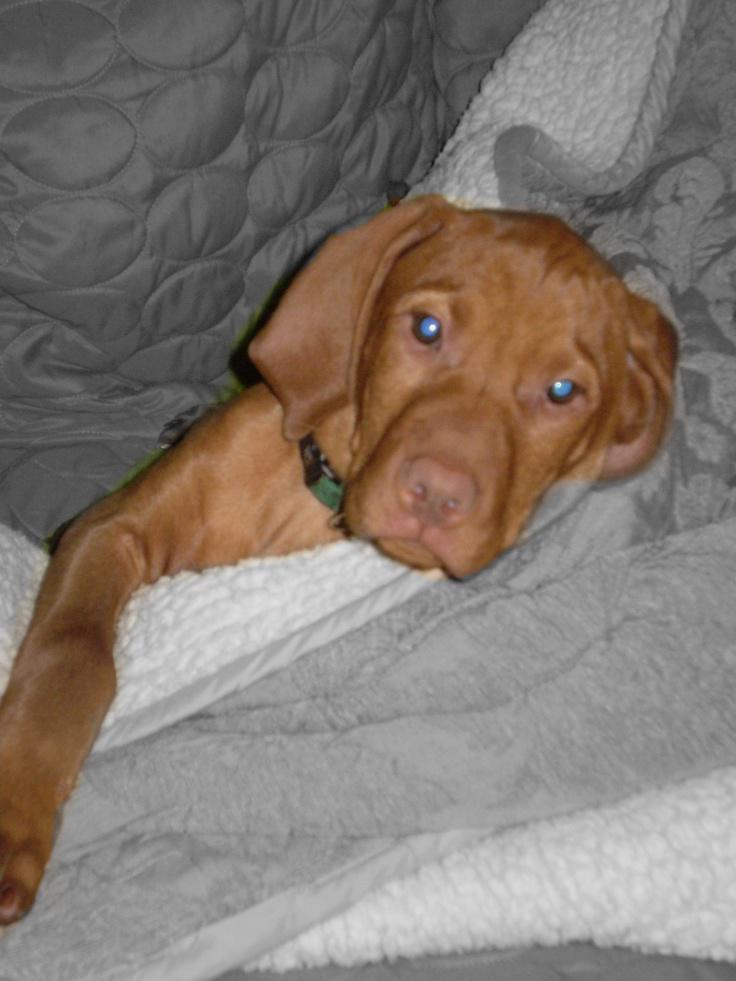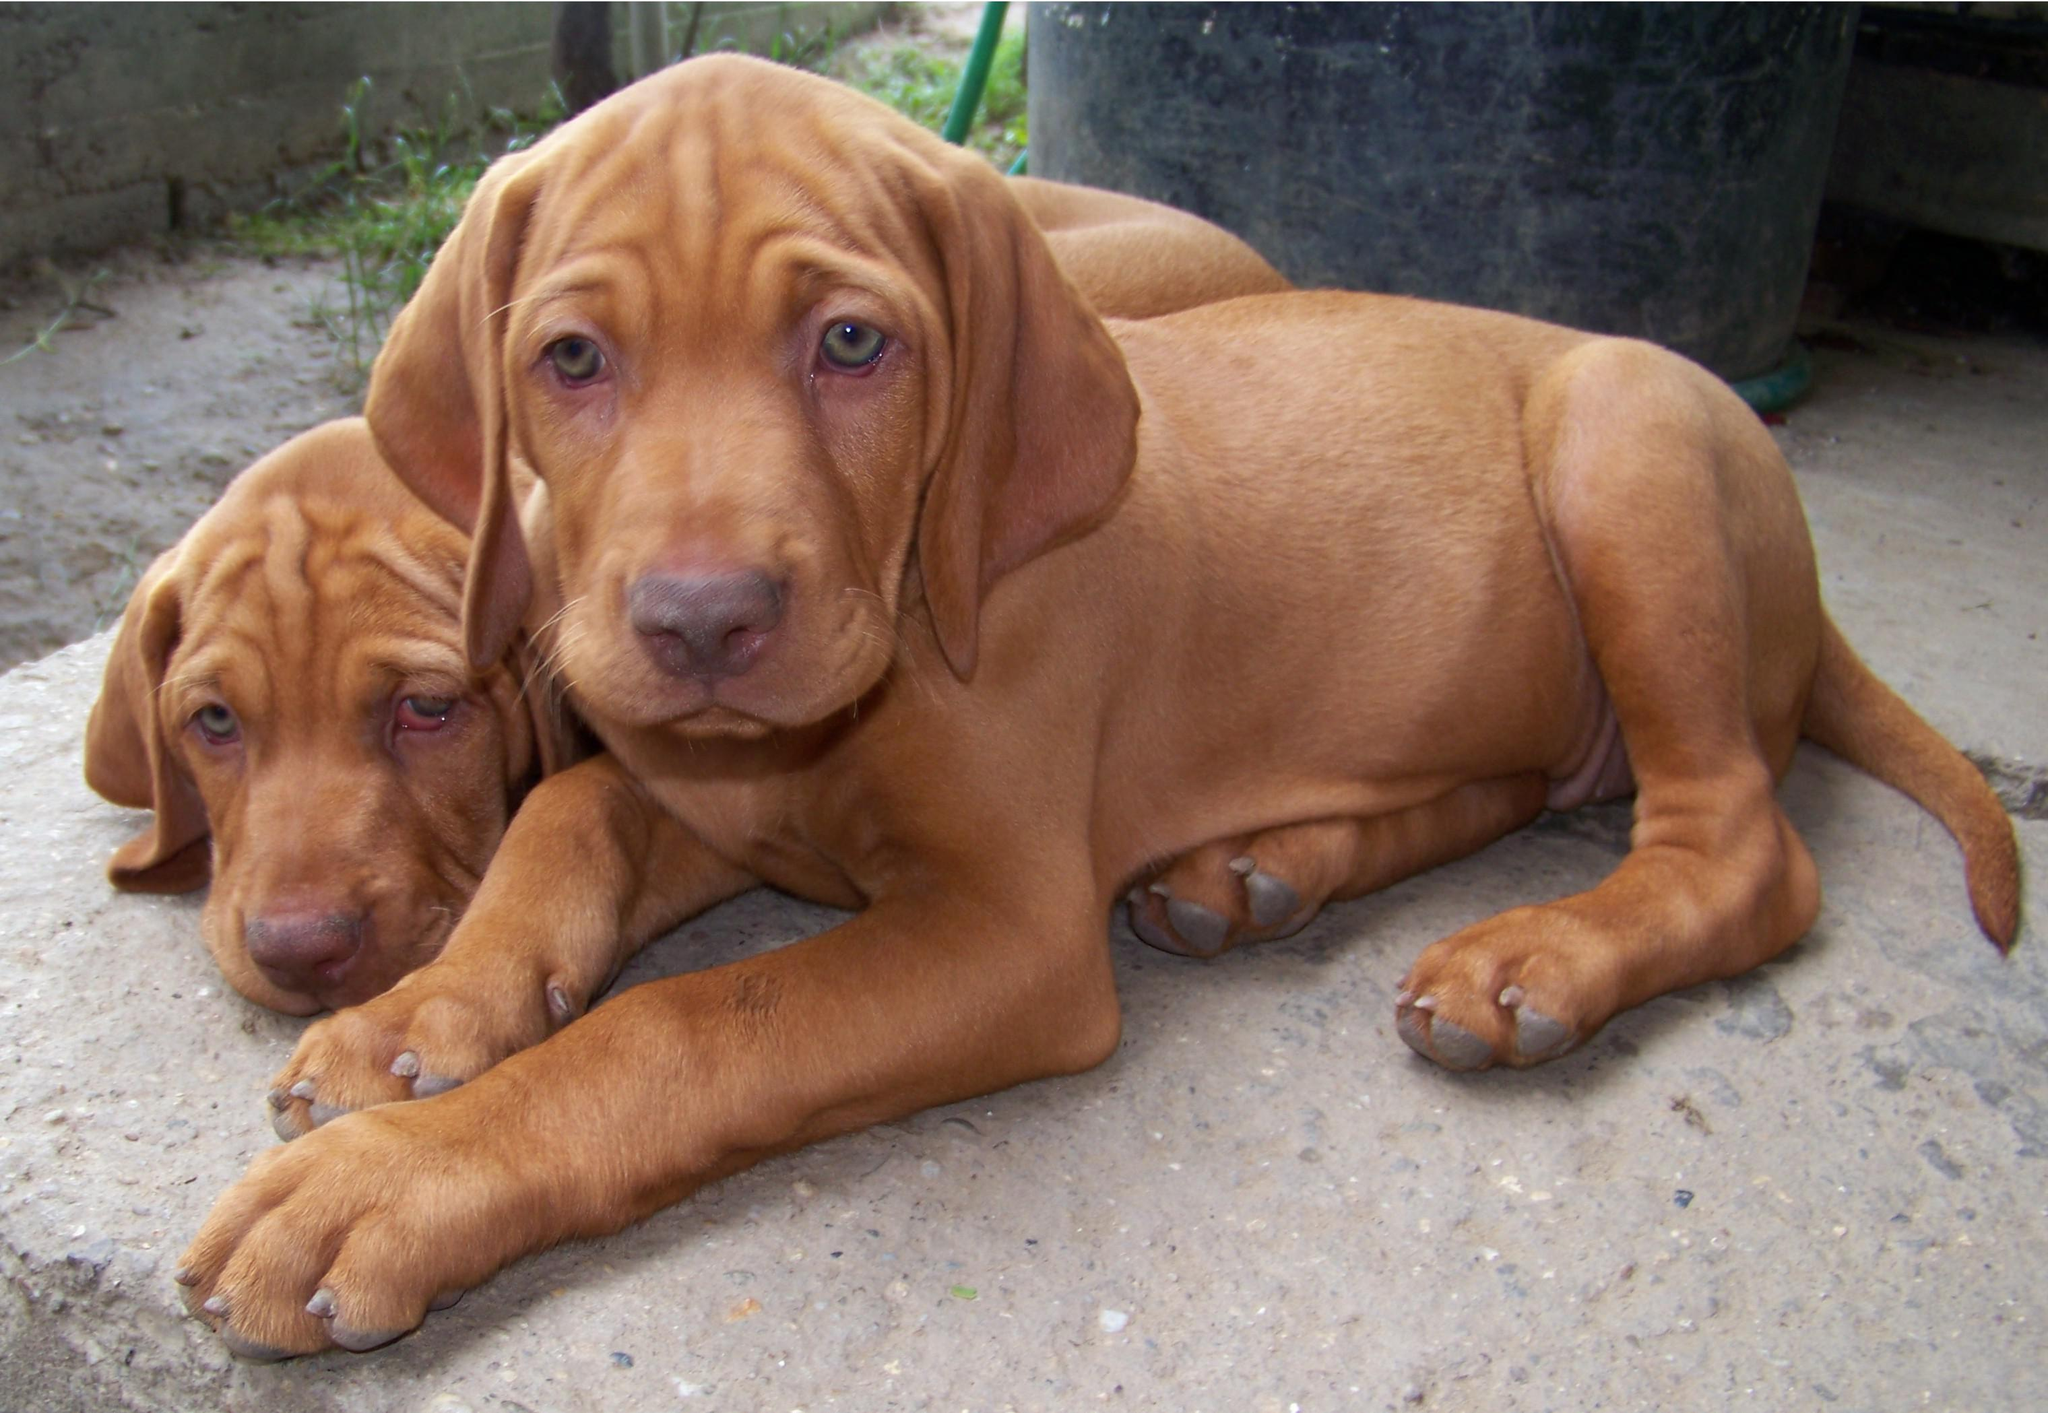The first image is the image on the left, the second image is the image on the right. Assess this claim about the two images: "There are three dogs.". Correct or not? Answer yes or no. Yes. The first image is the image on the left, the second image is the image on the right. For the images shown, is this caption "Each image contains just one dog, and the left image features a young dog reclining with its head upright and front paws forward." true? Answer yes or no. No. 